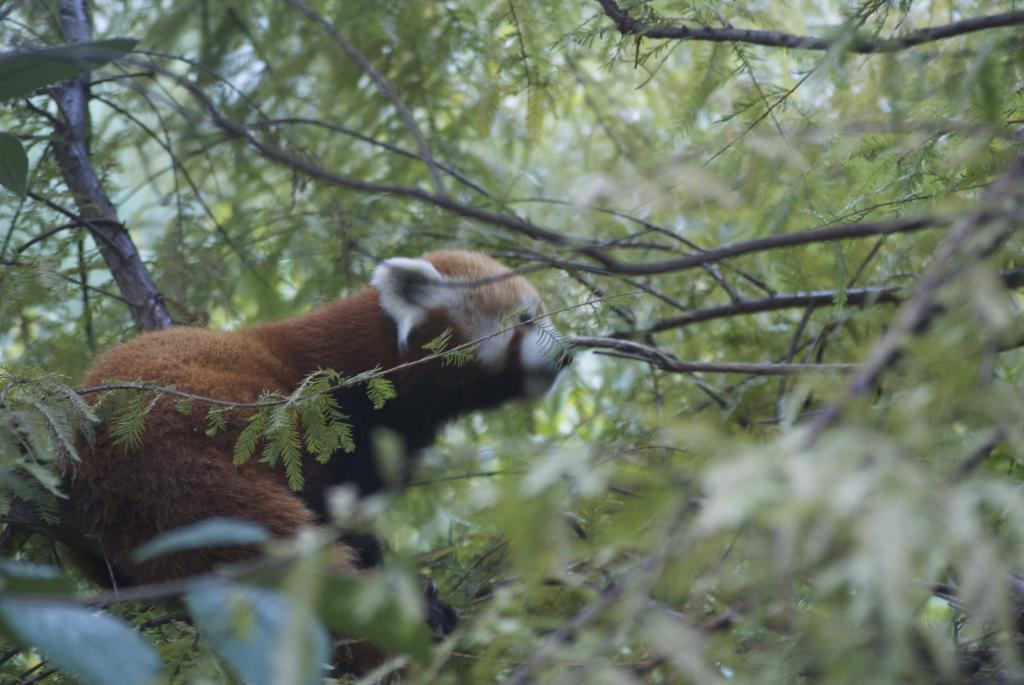What type of natural elements can be seen in the image? There are many plants and trees in the image. Is there any wildlife present in the image? Yes, there is an animal in the image. What is the color of the animal? The animal is brown in color. Are there any distinct features of the animal's appearance? Yes, the animal has white ears and nose. What type of insurance does the animal have in the image? There is no information about insurance in the image; it only features plants, trees, and an animal. 